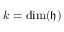Convert formula to latex. <formula><loc_0><loc_0><loc_500><loc_500>k = \dim ( { \mathfrak { h } } )</formula> 